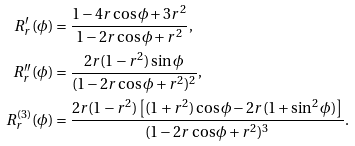Convert formula to latex. <formula><loc_0><loc_0><loc_500><loc_500>R ^ { \prime } _ { r } ( \phi ) & = \frac { 1 - 4 r \cos \phi + 3 r ^ { 2 } } { 1 - 2 r \cos \phi + r ^ { 2 } } , \\ R ^ { \prime \prime } _ { r } ( \phi ) & = \frac { 2 r ( 1 - r ^ { 2 } ) \sin \phi } { ( 1 - 2 r \cos \phi + r ^ { 2 } ) ^ { 2 } } , \\ R _ { r } ^ { ( 3 ) } ( \phi ) & = \frac { 2 r ( 1 - r ^ { 2 } ) \left [ ( 1 + r ^ { 2 } ) \cos \phi - 2 r ( 1 + \sin ^ { 2 } \phi ) \right ] } { ( 1 - 2 r \cos \phi + r ^ { 2 } ) ^ { 3 } } .</formula> 